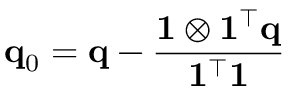Convert formula to latex. <formula><loc_0><loc_0><loc_500><loc_500>q _ { 0 } = q - \frac { 1 \otimes 1 ^ { \top } q } { 1 ^ { \top } 1 }</formula> 